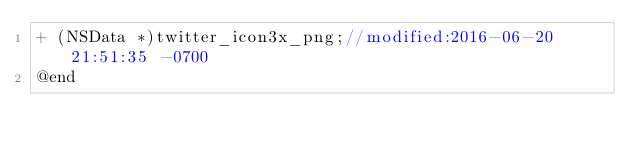Convert code to text. <code><loc_0><loc_0><loc_500><loc_500><_C_>+ (NSData *)twitter_icon3x_png;//modified:2016-06-20 21:51:35 -0700
@end
</code> 